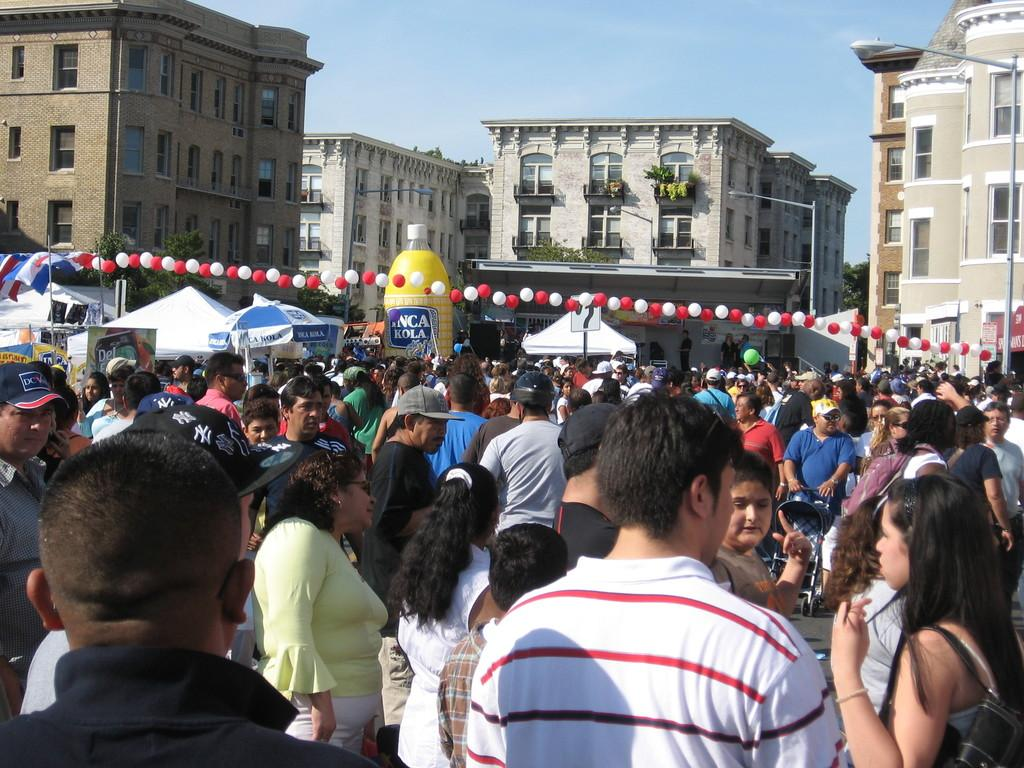What is happening in the image? There is a group of people in the image. Where are the people located? The people are standing in the town center. What can be seen in the background of the image? There are buildings visible in the background of the image. What type of tomatoes can be seen growing on the marble shop in the image? There is no tomato plant or marble shop present in the image. 